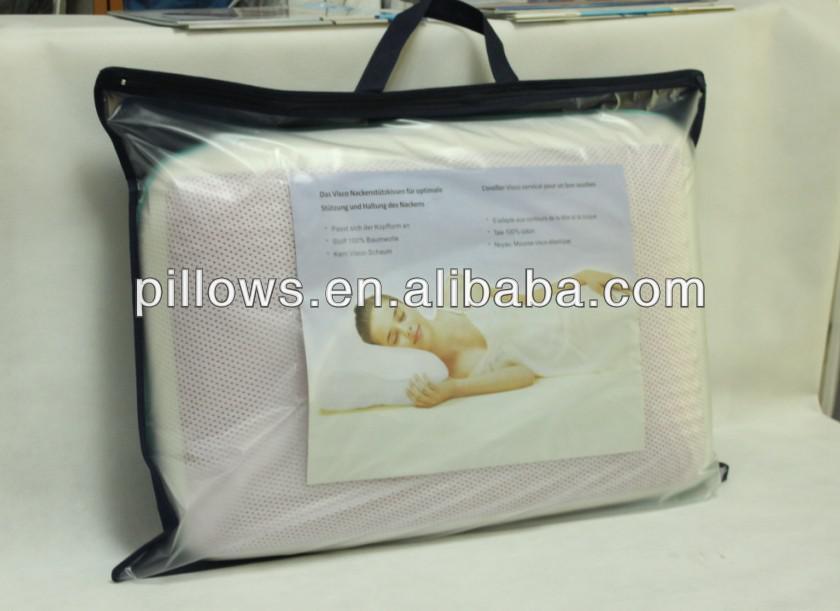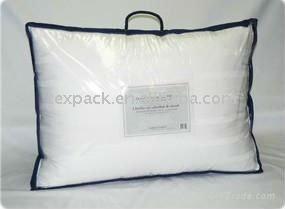The first image is the image on the left, the second image is the image on the right. Assess this claim about the two images: "An image shows a pillow in a transparent bag with a black handle and black edges.". Correct or not? Answer yes or no. Yes. 